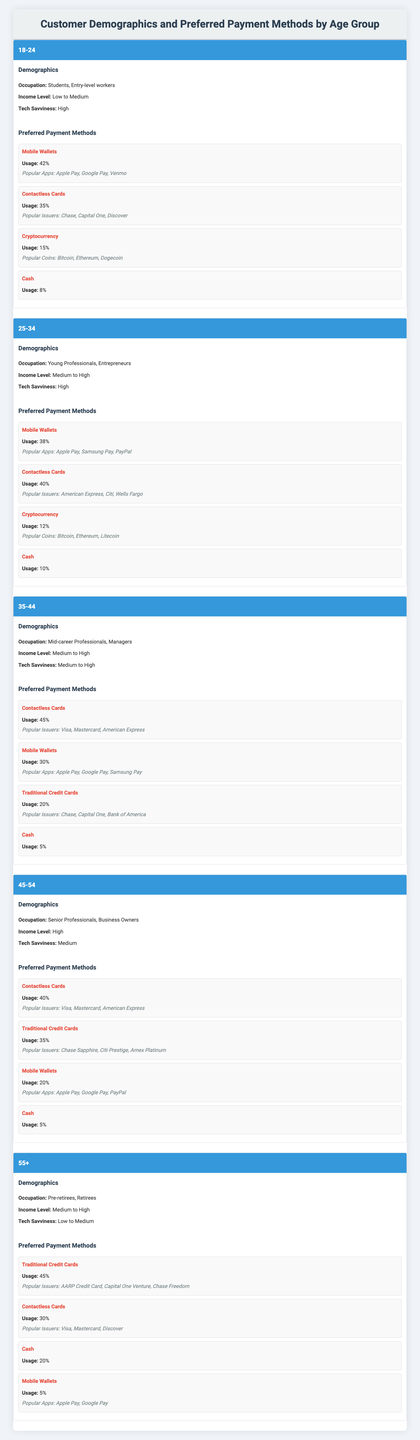What is the most preferred payment method among the 18-24 age group? According to the data, in the 18-24 age group, Mobile Wallets have the highest usage at 42%.
Answer: Mobile Wallets Which age group has the lowest usage of cash as a payment method? The age group 35-44 has the lowest cash usage at 5%.
Answer: 35-44 What percentage of the 45-54 age group prefers traditional credit cards? The table shows that 35% of the 45-54 age group uses traditional credit cards.
Answer: 35% How much higher is the usage of contactless cards in the 35-44 age group compared to the 25-34 age group? The 35-44 age group uses contactless cards at 45%, while the 25-34 age group uses them at 40%. The difference is 45% - 40% = 5%.
Answer: 5% Which payment method has the highest usage among those aged 55 and older? For the 55+ age group, Traditional Credit Cards have the highest usage at 45%.
Answer: Traditional Credit Cards Is the popularity of cryptocurrency higher in the 18-24 age group than in the 35-44 age group? The 18-24 age group has cryptocurrency usage at 15%, whereas the 35-44 age group has it at 20%. So, it is not higher in the 18-24 age group.
Answer: No What is the average percentage of mobile wallet usage across all age groups? To find the average, we add the mobile wallet usage percentages: 42 + 38 + 30 + 20 + 5 = 135, then divide by 5 (the number of age groups), which results in 135 / 5 = 27%.
Answer: 27% Which payment method is preferred by the oldest age group (55+) the most? According to the data, Traditional Credit Cards are the most preferred payment method among the 55+ age group, at 45%.
Answer: Traditional Credit Cards Is the tech savviness of the 25-34 age group higher than that of the 45-54 age group? The 25-34 age group is categorized as "High" tech savviness, while the 45-54 age group is categorized as "Medium." Hence, 25-34 is higher in tech savviness.
Answer: Yes What percentage of young professionals (25-34) prefer mobile wallets compared to students (18-24)? The 25-34 age group prefers mobile wallets at 38%, while the 18-24 age group prefers them at 42%. Thus, mobile wallet usage is lower by 4% in the 25-34 age group.
Answer: 4% lower How does the income level of the 55+ age group compare to the 18-24 age group? The 55+ age group has a "Medium to High" income level, while the 18-24 age group has a "Low to Medium" income level. Hence, the 55+ age group has a higher income level.
Answer: Higher 